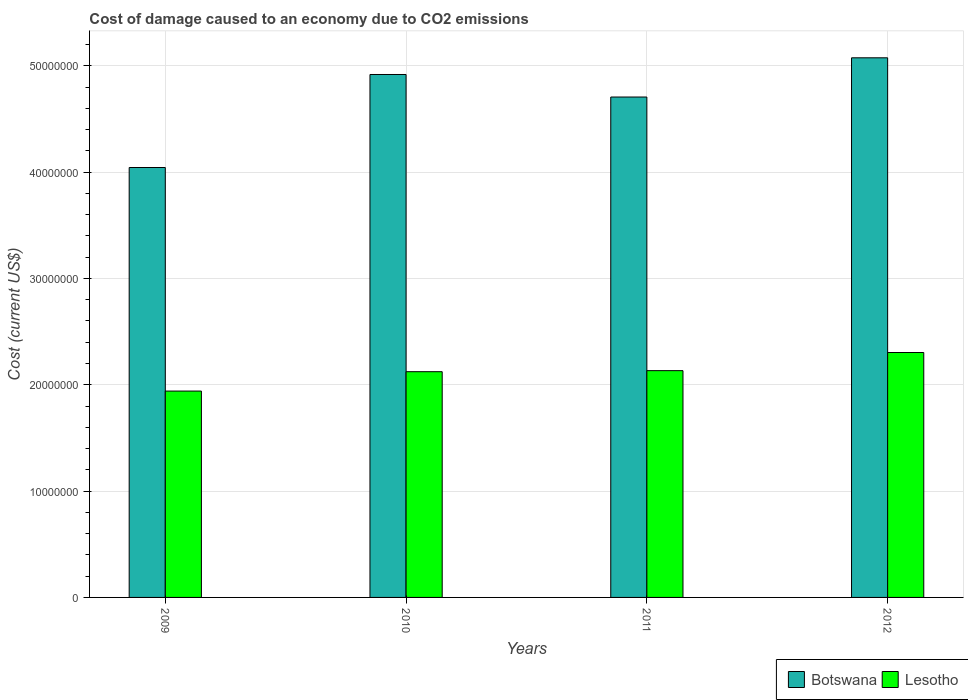How many bars are there on the 2nd tick from the right?
Offer a terse response. 2. What is the label of the 4th group of bars from the left?
Ensure brevity in your answer.  2012. What is the cost of damage caused due to CO2 emissisons in Lesotho in 2010?
Your answer should be compact. 2.12e+07. Across all years, what is the maximum cost of damage caused due to CO2 emissisons in Botswana?
Make the answer very short. 5.07e+07. Across all years, what is the minimum cost of damage caused due to CO2 emissisons in Botswana?
Provide a succinct answer. 4.04e+07. In which year was the cost of damage caused due to CO2 emissisons in Lesotho minimum?
Keep it short and to the point. 2009. What is the total cost of damage caused due to CO2 emissisons in Lesotho in the graph?
Ensure brevity in your answer.  8.50e+07. What is the difference between the cost of damage caused due to CO2 emissisons in Botswana in 2010 and that in 2012?
Provide a succinct answer. -1.57e+06. What is the difference between the cost of damage caused due to CO2 emissisons in Botswana in 2011 and the cost of damage caused due to CO2 emissisons in Lesotho in 2010?
Keep it short and to the point. 2.58e+07. What is the average cost of damage caused due to CO2 emissisons in Botswana per year?
Your answer should be very brief. 4.69e+07. In the year 2011, what is the difference between the cost of damage caused due to CO2 emissisons in Lesotho and cost of damage caused due to CO2 emissisons in Botswana?
Provide a succinct answer. -2.57e+07. What is the ratio of the cost of damage caused due to CO2 emissisons in Lesotho in 2009 to that in 2010?
Provide a short and direct response. 0.91. Is the cost of damage caused due to CO2 emissisons in Botswana in 2010 less than that in 2011?
Your response must be concise. No. Is the difference between the cost of damage caused due to CO2 emissisons in Lesotho in 2011 and 2012 greater than the difference between the cost of damage caused due to CO2 emissisons in Botswana in 2011 and 2012?
Keep it short and to the point. Yes. What is the difference between the highest and the second highest cost of damage caused due to CO2 emissisons in Botswana?
Offer a terse response. 1.57e+06. What is the difference between the highest and the lowest cost of damage caused due to CO2 emissisons in Botswana?
Ensure brevity in your answer.  1.03e+07. In how many years, is the cost of damage caused due to CO2 emissisons in Botswana greater than the average cost of damage caused due to CO2 emissisons in Botswana taken over all years?
Ensure brevity in your answer.  3. What does the 2nd bar from the left in 2010 represents?
Provide a succinct answer. Lesotho. What does the 2nd bar from the right in 2009 represents?
Your response must be concise. Botswana. How many bars are there?
Your answer should be compact. 8. What is the difference between two consecutive major ticks on the Y-axis?
Provide a succinct answer. 1.00e+07. Are the values on the major ticks of Y-axis written in scientific E-notation?
Keep it short and to the point. No. Does the graph contain any zero values?
Your response must be concise. No. Does the graph contain grids?
Offer a terse response. Yes. What is the title of the graph?
Offer a very short reply. Cost of damage caused to an economy due to CO2 emissions. What is the label or title of the X-axis?
Provide a succinct answer. Years. What is the label or title of the Y-axis?
Provide a short and direct response. Cost (current US$). What is the Cost (current US$) of Botswana in 2009?
Make the answer very short. 4.04e+07. What is the Cost (current US$) in Lesotho in 2009?
Your response must be concise. 1.94e+07. What is the Cost (current US$) of Botswana in 2010?
Offer a terse response. 4.92e+07. What is the Cost (current US$) of Lesotho in 2010?
Ensure brevity in your answer.  2.12e+07. What is the Cost (current US$) in Botswana in 2011?
Ensure brevity in your answer.  4.71e+07. What is the Cost (current US$) of Lesotho in 2011?
Offer a very short reply. 2.13e+07. What is the Cost (current US$) of Botswana in 2012?
Make the answer very short. 5.07e+07. What is the Cost (current US$) of Lesotho in 2012?
Provide a succinct answer. 2.30e+07. Across all years, what is the maximum Cost (current US$) of Botswana?
Your answer should be very brief. 5.07e+07. Across all years, what is the maximum Cost (current US$) of Lesotho?
Your answer should be very brief. 2.30e+07. Across all years, what is the minimum Cost (current US$) in Botswana?
Give a very brief answer. 4.04e+07. Across all years, what is the minimum Cost (current US$) of Lesotho?
Your response must be concise. 1.94e+07. What is the total Cost (current US$) in Botswana in the graph?
Offer a very short reply. 1.87e+08. What is the total Cost (current US$) of Lesotho in the graph?
Offer a terse response. 8.50e+07. What is the difference between the Cost (current US$) of Botswana in 2009 and that in 2010?
Give a very brief answer. -8.75e+06. What is the difference between the Cost (current US$) of Lesotho in 2009 and that in 2010?
Ensure brevity in your answer.  -1.82e+06. What is the difference between the Cost (current US$) in Botswana in 2009 and that in 2011?
Ensure brevity in your answer.  -6.63e+06. What is the difference between the Cost (current US$) of Lesotho in 2009 and that in 2011?
Your response must be concise. -1.92e+06. What is the difference between the Cost (current US$) in Botswana in 2009 and that in 2012?
Give a very brief answer. -1.03e+07. What is the difference between the Cost (current US$) in Lesotho in 2009 and that in 2012?
Your response must be concise. -3.63e+06. What is the difference between the Cost (current US$) in Botswana in 2010 and that in 2011?
Your answer should be compact. 2.12e+06. What is the difference between the Cost (current US$) of Lesotho in 2010 and that in 2011?
Offer a very short reply. -9.74e+04. What is the difference between the Cost (current US$) in Botswana in 2010 and that in 2012?
Your answer should be very brief. -1.57e+06. What is the difference between the Cost (current US$) of Lesotho in 2010 and that in 2012?
Provide a succinct answer. -1.80e+06. What is the difference between the Cost (current US$) of Botswana in 2011 and that in 2012?
Make the answer very short. -3.69e+06. What is the difference between the Cost (current US$) in Lesotho in 2011 and that in 2012?
Your answer should be very brief. -1.71e+06. What is the difference between the Cost (current US$) in Botswana in 2009 and the Cost (current US$) in Lesotho in 2010?
Provide a short and direct response. 1.92e+07. What is the difference between the Cost (current US$) of Botswana in 2009 and the Cost (current US$) of Lesotho in 2011?
Make the answer very short. 1.91e+07. What is the difference between the Cost (current US$) of Botswana in 2009 and the Cost (current US$) of Lesotho in 2012?
Keep it short and to the point. 1.74e+07. What is the difference between the Cost (current US$) in Botswana in 2010 and the Cost (current US$) in Lesotho in 2011?
Provide a short and direct response. 2.79e+07. What is the difference between the Cost (current US$) of Botswana in 2010 and the Cost (current US$) of Lesotho in 2012?
Ensure brevity in your answer.  2.61e+07. What is the difference between the Cost (current US$) of Botswana in 2011 and the Cost (current US$) of Lesotho in 2012?
Ensure brevity in your answer.  2.40e+07. What is the average Cost (current US$) of Botswana per year?
Offer a very short reply. 4.69e+07. What is the average Cost (current US$) in Lesotho per year?
Provide a succinct answer. 2.12e+07. In the year 2009, what is the difference between the Cost (current US$) in Botswana and Cost (current US$) in Lesotho?
Keep it short and to the point. 2.10e+07. In the year 2010, what is the difference between the Cost (current US$) in Botswana and Cost (current US$) in Lesotho?
Provide a succinct answer. 2.79e+07. In the year 2011, what is the difference between the Cost (current US$) in Botswana and Cost (current US$) in Lesotho?
Your response must be concise. 2.57e+07. In the year 2012, what is the difference between the Cost (current US$) in Botswana and Cost (current US$) in Lesotho?
Give a very brief answer. 2.77e+07. What is the ratio of the Cost (current US$) in Botswana in 2009 to that in 2010?
Offer a very short reply. 0.82. What is the ratio of the Cost (current US$) in Lesotho in 2009 to that in 2010?
Ensure brevity in your answer.  0.91. What is the ratio of the Cost (current US$) in Botswana in 2009 to that in 2011?
Your response must be concise. 0.86. What is the ratio of the Cost (current US$) in Lesotho in 2009 to that in 2011?
Your answer should be compact. 0.91. What is the ratio of the Cost (current US$) of Botswana in 2009 to that in 2012?
Provide a succinct answer. 0.8. What is the ratio of the Cost (current US$) of Lesotho in 2009 to that in 2012?
Your answer should be compact. 0.84. What is the ratio of the Cost (current US$) of Botswana in 2010 to that in 2011?
Your answer should be compact. 1.04. What is the ratio of the Cost (current US$) of Botswana in 2010 to that in 2012?
Provide a short and direct response. 0.97. What is the ratio of the Cost (current US$) of Lesotho in 2010 to that in 2012?
Give a very brief answer. 0.92. What is the ratio of the Cost (current US$) of Botswana in 2011 to that in 2012?
Keep it short and to the point. 0.93. What is the ratio of the Cost (current US$) in Lesotho in 2011 to that in 2012?
Your answer should be very brief. 0.93. What is the difference between the highest and the second highest Cost (current US$) of Botswana?
Make the answer very short. 1.57e+06. What is the difference between the highest and the second highest Cost (current US$) in Lesotho?
Ensure brevity in your answer.  1.71e+06. What is the difference between the highest and the lowest Cost (current US$) of Botswana?
Your response must be concise. 1.03e+07. What is the difference between the highest and the lowest Cost (current US$) in Lesotho?
Offer a terse response. 3.63e+06. 